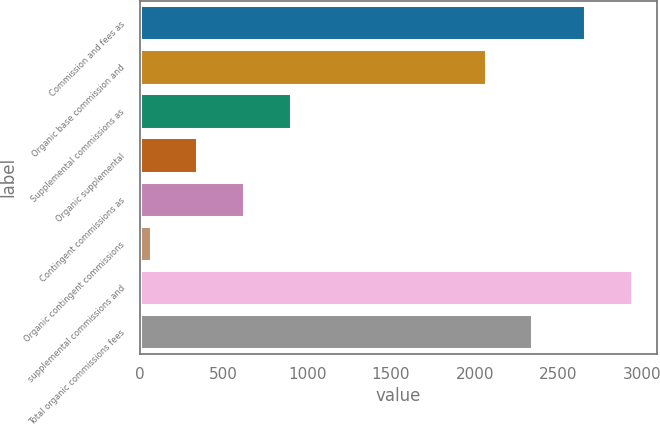Convert chart. <chart><loc_0><loc_0><loc_500><loc_500><bar_chart><fcel>Commission and fees as<fcel>Organic base commission and<fcel>Supplemental commissions as<fcel>Organic supplemental<fcel>Contingent commissions as<fcel>Organic contingent commissions<fcel>supplemental commissions and<fcel>Total organic commissions fees<nl><fcel>2660<fcel>2064.8<fcel>899.97<fcel>343.19<fcel>621.58<fcel>64.8<fcel>2938.39<fcel>2343.19<nl></chart> 